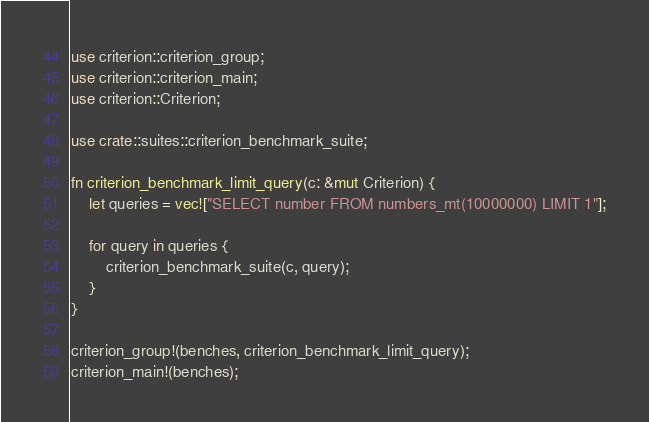<code> <loc_0><loc_0><loc_500><loc_500><_Rust_>
use criterion::criterion_group;
use criterion::criterion_main;
use criterion::Criterion;

use crate::suites::criterion_benchmark_suite;

fn criterion_benchmark_limit_query(c: &mut Criterion) {
    let queries = vec!["SELECT number FROM numbers_mt(10000000) LIMIT 1"];

    for query in queries {
        criterion_benchmark_suite(c, query);
    }
}

criterion_group!(benches, criterion_benchmark_limit_query);
criterion_main!(benches);
</code> 